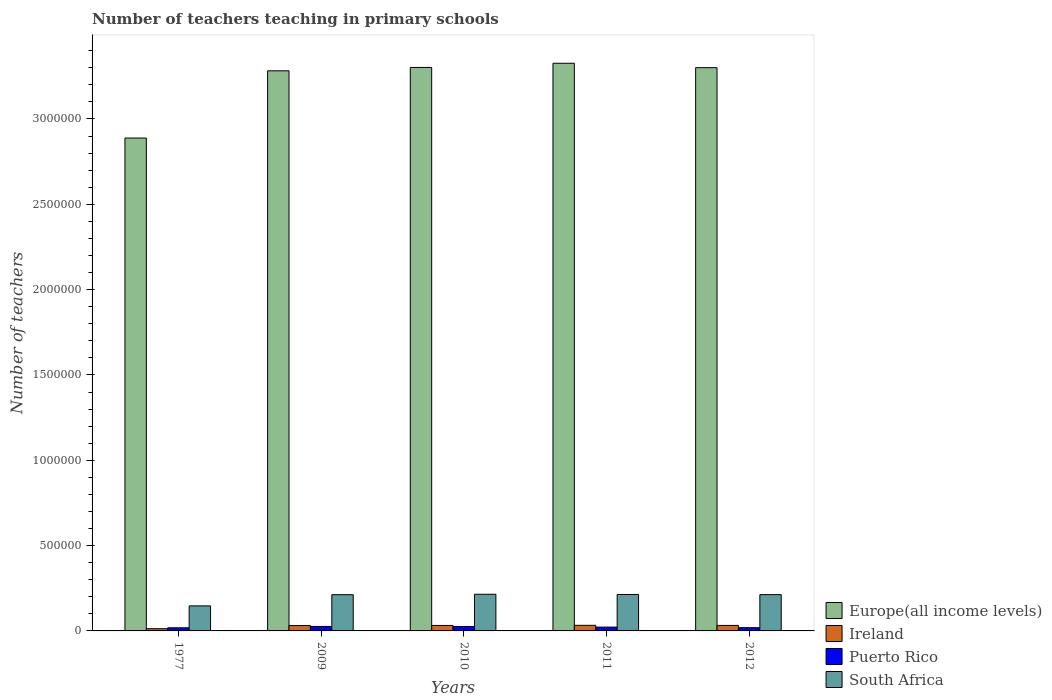How many different coloured bars are there?
Your answer should be very brief. 4. Are the number of bars on each tick of the X-axis equal?
Give a very brief answer. Yes. What is the label of the 5th group of bars from the left?
Your response must be concise. 2012. In how many cases, is the number of bars for a given year not equal to the number of legend labels?
Offer a very short reply. 0. What is the number of teachers teaching in primary schools in Puerto Rico in 1977?
Your response must be concise. 1.83e+04. Across all years, what is the maximum number of teachers teaching in primary schools in Europe(all income levels)?
Ensure brevity in your answer.  3.33e+06. Across all years, what is the minimum number of teachers teaching in primary schools in South Africa?
Keep it short and to the point. 1.47e+05. In which year was the number of teachers teaching in primary schools in Europe(all income levels) maximum?
Provide a succinct answer. 2011. What is the total number of teachers teaching in primary schools in Europe(all income levels) in the graph?
Give a very brief answer. 1.61e+07. What is the difference between the number of teachers teaching in primary schools in Europe(all income levels) in 2009 and that in 2012?
Your answer should be compact. -1.84e+04. What is the difference between the number of teachers teaching in primary schools in South Africa in 2011 and the number of teachers teaching in primary schools in Europe(all income levels) in 2010?
Ensure brevity in your answer.  -3.09e+06. What is the average number of teachers teaching in primary schools in Europe(all income levels) per year?
Ensure brevity in your answer.  3.22e+06. In the year 1977, what is the difference between the number of teachers teaching in primary schools in Puerto Rico and number of teachers teaching in primary schools in Ireland?
Your response must be concise. 5264. In how many years, is the number of teachers teaching in primary schools in Ireland greater than 3300000?
Keep it short and to the point. 0. What is the ratio of the number of teachers teaching in primary schools in South Africa in 1977 to that in 2009?
Your answer should be compact. 0.69. Is the number of teachers teaching in primary schools in Ireland in 1977 less than that in 2009?
Make the answer very short. Yes. What is the difference between the highest and the second highest number of teachers teaching in primary schools in Ireland?
Provide a short and direct response. 581. What is the difference between the highest and the lowest number of teachers teaching in primary schools in South Africa?
Give a very brief answer. 6.81e+04. What does the 4th bar from the left in 2010 represents?
Ensure brevity in your answer.  South Africa. What does the 4th bar from the right in 2011 represents?
Give a very brief answer. Europe(all income levels). How many bars are there?
Keep it short and to the point. 20. How many years are there in the graph?
Ensure brevity in your answer.  5. What is the difference between two consecutive major ticks on the Y-axis?
Keep it short and to the point. 5.00e+05. Does the graph contain any zero values?
Provide a succinct answer. No. Does the graph contain grids?
Your answer should be very brief. No. Where does the legend appear in the graph?
Give a very brief answer. Bottom right. How many legend labels are there?
Provide a short and direct response. 4. What is the title of the graph?
Your answer should be very brief. Number of teachers teaching in primary schools. Does "Benin" appear as one of the legend labels in the graph?
Offer a very short reply. No. What is the label or title of the Y-axis?
Give a very brief answer. Number of teachers. What is the Number of teachers in Europe(all income levels) in 1977?
Ensure brevity in your answer.  2.89e+06. What is the Number of teachers of Ireland in 1977?
Your response must be concise. 1.31e+04. What is the Number of teachers in Puerto Rico in 1977?
Offer a very short reply. 1.83e+04. What is the Number of teachers of South Africa in 1977?
Your answer should be compact. 1.47e+05. What is the Number of teachers of Europe(all income levels) in 2009?
Provide a short and direct response. 3.28e+06. What is the Number of teachers in Ireland in 2009?
Your answer should be very brief. 3.15e+04. What is the Number of teachers of Puerto Rico in 2009?
Your answer should be compact. 2.61e+04. What is the Number of teachers in South Africa in 2009?
Offer a terse response. 2.12e+05. What is the Number of teachers of Europe(all income levels) in 2010?
Your response must be concise. 3.30e+06. What is the Number of teachers of Ireland in 2010?
Your answer should be compact. 3.20e+04. What is the Number of teachers in Puerto Rico in 2010?
Offer a terse response. 2.57e+04. What is the Number of teachers of South Africa in 2010?
Give a very brief answer. 2.15e+05. What is the Number of teachers in Europe(all income levels) in 2011?
Your answer should be very brief. 3.33e+06. What is the Number of teachers of Ireland in 2011?
Keep it short and to the point. 3.28e+04. What is the Number of teachers of Puerto Rico in 2011?
Offer a terse response. 2.24e+04. What is the Number of teachers in South Africa in 2011?
Your answer should be very brief. 2.13e+05. What is the Number of teachers in Europe(all income levels) in 2012?
Give a very brief answer. 3.30e+06. What is the Number of teachers of Ireland in 2012?
Offer a terse response. 3.23e+04. What is the Number of teachers in Puerto Rico in 2012?
Your response must be concise. 1.91e+04. What is the Number of teachers of South Africa in 2012?
Give a very brief answer. 2.13e+05. Across all years, what is the maximum Number of teachers of Europe(all income levels)?
Give a very brief answer. 3.33e+06. Across all years, what is the maximum Number of teachers of Ireland?
Make the answer very short. 3.28e+04. Across all years, what is the maximum Number of teachers in Puerto Rico?
Provide a succinct answer. 2.61e+04. Across all years, what is the maximum Number of teachers of South Africa?
Provide a short and direct response. 2.15e+05. Across all years, what is the minimum Number of teachers in Europe(all income levels)?
Your response must be concise. 2.89e+06. Across all years, what is the minimum Number of teachers in Ireland?
Provide a succinct answer. 1.31e+04. Across all years, what is the minimum Number of teachers of Puerto Rico?
Provide a succinct answer. 1.83e+04. Across all years, what is the minimum Number of teachers in South Africa?
Your answer should be compact. 1.47e+05. What is the total Number of teachers of Europe(all income levels) in the graph?
Ensure brevity in your answer.  1.61e+07. What is the total Number of teachers of Ireland in the graph?
Your answer should be compact. 1.42e+05. What is the total Number of teachers of Puerto Rico in the graph?
Offer a very short reply. 1.12e+05. What is the total Number of teachers in South Africa in the graph?
Make the answer very short. 1.00e+06. What is the difference between the Number of teachers of Europe(all income levels) in 1977 and that in 2009?
Give a very brief answer. -3.94e+05. What is the difference between the Number of teachers of Ireland in 1977 and that in 2009?
Offer a terse response. -1.85e+04. What is the difference between the Number of teachers of Puerto Rico in 1977 and that in 2009?
Give a very brief answer. -7718. What is the difference between the Number of teachers in South Africa in 1977 and that in 2009?
Offer a terse response. -6.55e+04. What is the difference between the Number of teachers of Europe(all income levels) in 1977 and that in 2010?
Ensure brevity in your answer.  -4.14e+05. What is the difference between the Number of teachers of Ireland in 1977 and that in 2010?
Provide a succinct answer. -1.90e+04. What is the difference between the Number of teachers of Puerto Rico in 1977 and that in 2010?
Make the answer very short. -7368. What is the difference between the Number of teachers in South Africa in 1977 and that in 2010?
Make the answer very short. -6.81e+04. What is the difference between the Number of teachers of Europe(all income levels) in 1977 and that in 2011?
Provide a succinct answer. -4.38e+05. What is the difference between the Number of teachers of Ireland in 1977 and that in 2011?
Provide a short and direct response. -1.98e+04. What is the difference between the Number of teachers of Puerto Rico in 1977 and that in 2011?
Make the answer very short. -4055. What is the difference between the Number of teachers of South Africa in 1977 and that in 2011?
Offer a very short reply. -6.67e+04. What is the difference between the Number of teachers in Europe(all income levels) in 1977 and that in 2012?
Your response must be concise. -4.12e+05. What is the difference between the Number of teachers of Ireland in 1977 and that in 2012?
Your response must be concise. -1.92e+04. What is the difference between the Number of teachers of Puerto Rico in 1977 and that in 2012?
Ensure brevity in your answer.  -741. What is the difference between the Number of teachers of South Africa in 1977 and that in 2012?
Keep it short and to the point. -6.59e+04. What is the difference between the Number of teachers in Europe(all income levels) in 2009 and that in 2010?
Offer a terse response. -1.97e+04. What is the difference between the Number of teachers of Ireland in 2009 and that in 2010?
Keep it short and to the point. -494. What is the difference between the Number of teachers in Puerto Rico in 2009 and that in 2010?
Offer a very short reply. 350. What is the difference between the Number of teachers in South Africa in 2009 and that in 2010?
Provide a short and direct response. -2584. What is the difference between the Number of teachers of Europe(all income levels) in 2009 and that in 2011?
Give a very brief answer. -4.43e+04. What is the difference between the Number of teachers of Ireland in 2009 and that in 2011?
Offer a very short reply. -1299. What is the difference between the Number of teachers of Puerto Rico in 2009 and that in 2011?
Offer a very short reply. 3663. What is the difference between the Number of teachers in South Africa in 2009 and that in 2011?
Ensure brevity in your answer.  -1144. What is the difference between the Number of teachers in Europe(all income levels) in 2009 and that in 2012?
Give a very brief answer. -1.84e+04. What is the difference between the Number of teachers of Ireland in 2009 and that in 2012?
Give a very brief answer. -718. What is the difference between the Number of teachers of Puerto Rico in 2009 and that in 2012?
Make the answer very short. 6977. What is the difference between the Number of teachers of South Africa in 2009 and that in 2012?
Provide a short and direct response. -361. What is the difference between the Number of teachers of Europe(all income levels) in 2010 and that in 2011?
Offer a terse response. -2.46e+04. What is the difference between the Number of teachers of Ireland in 2010 and that in 2011?
Your answer should be compact. -805. What is the difference between the Number of teachers of Puerto Rico in 2010 and that in 2011?
Give a very brief answer. 3313. What is the difference between the Number of teachers of South Africa in 2010 and that in 2011?
Your answer should be very brief. 1440. What is the difference between the Number of teachers in Europe(all income levels) in 2010 and that in 2012?
Offer a very short reply. 1240.5. What is the difference between the Number of teachers of Ireland in 2010 and that in 2012?
Your response must be concise. -224. What is the difference between the Number of teachers of Puerto Rico in 2010 and that in 2012?
Provide a succinct answer. 6627. What is the difference between the Number of teachers in South Africa in 2010 and that in 2012?
Your answer should be compact. 2223. What is the difference between the Number of teachers of Europe(all income levels) in 2011 and that in 2012?
Your answer should be very brief. 2.58e+04. What is the difference between the Number of teachers in Ireland in 2011 and that in 2012?
Your answer should be very brief. 581. What is the difference between the Number of teachers in Puerto Rico in 2011 and that in 2012?
Ensure brevity in your answer.  3314. What is the difference between the Number of teachers in South Africa in 2011 and that in 2012?
Provide a succinct answer. 783. What is the difference between the Number of teachers in Europe(all income levels) in 1977 and the Number of teachers in Ireland in 2009?
Offer a terse response. 2.86e+06. What is the difference between the Number of teachers in Europe(all income levels) in 1977 and the Number of teachers in Puerto Rico in 2009?
Offer a terse response. 2.86e+06. What is the difference between the Number of teachers of Europe(all income levels) in 1977 and the Number of teachers of South Africa in 2009?
Your answer should be compact. 2.68e+06. What is the difference between the Number of teachers in Ireland in 1977 and the Number of teachers in Puerto Rico in 2009?
Your response must be concise. -1.30e+04. What is the difference between the Number of teachers of Ireland in 1977 and the Number of teachers of South Africa in 2009?
Ensure brevity in your answer.  -1.99e+05. What is the difference between the Number of teachers in Puerto Rico in 1977 and the Number of teachers in South Africa in 2009?
Keep it short and to the point. -1.94e+05. What is the difference between the Number of teachers in Europe(all income levels) in 1977 and the Number of teachers in Ireland in 2010?
Provide a succinct answer. 2.86e+06. What is the difference between the Number of teachers in Europe(all income levels) in 1977 and the Number of teachers in Puerto Rico in 2010?
Your answer should be very brief. 2.86e+06. What is the difference between the Number of teachers of Europe(all income levels) in 1977 and the Number of teachers of South Africa in 2010?
Provide a short and direct response. 2.67e+06. What is the difference between the Number of teachers of Ireland in 1977 and the Number of teachers of Puerto Rico in 2010?
Keep it short and to the point. -1.26e+04. What is the difference between the Number of teachers of Ireland in 1977 and the Number of teachers of South Africa in 2010?
Provide a succinct answer. -2.02e+05. What is the difference between the Number of teachers of Puerto Rico in 1977 and the Number of teachers of South Africa in 2010?
Ensure brevity in your answer.  -1.97e+05. What is the difference between the Number of teachers in Europe(all income levels) in 1977 and the Number of teachers in Ireland in 2011?
Ensure brevity in your answer.  2.86e+06. What is the difference between the Number of teachers in Europe(all income levels) in 1977 and the Number of teachers in Puerto Rico in 2011?
Provide a short and direct response. 2.87e+06. What is the difference between the Number of teachers in Europe(all income levels) in 1977 and the Number of teachers in South Africa in 2011?
Give a very brief answer. 2.67e+06. What is the difference between the Number of teachers of Ireland in 1977 and the Number of teachers of Puerto Rico in 2011?
Ensure brevity in your answer.  -9319. What is the difference between the Number of teachers in Ireland in 1977 and the Number of teachers in South Africa in 2011?
Keep it short and to the point. -2.00e+05. What is the difference between the Number of teachers in Puerto Rico in 1977 and the Number of teachers in South Africa in 2011?
Make the answer very short. -1.95e+05. What is the difference between the Number of teachers in Europe(all income levels) in 1977 and the Number of teachers in Ireland in 2012?
Your answer should be very brief. 2.86e+06. What is the difference between the Number of teachers of Europe(all income levels) in 1977 and the Number of teachers of Puerto Rico in 2012?
Give a very brief answer. 2.87e+06. What is the difference between the Number of teachers of Europe(all income levels) in 1977 and the Number of teachers of South Africa in 2012?
Your answer should be very brief. 2.68e+06. What is the difference between the Number of teachers of Ireland in 1977 and the Number of teachers of Puerto Rico in 2012?
Keep it short and to the point. -6005. What is the difference between the Number of teachers in Ireland in 1977 and the Number of teachers in South Africa in 2012?
Make the answer very short. -2.00e+05. What is the difference between the Number of teachers in Puerto Rico in 1977 and the Number of teachers in South Africa in 2012?
Offer a terse response. -1.94e+05. What is the difference between the Number of teachers of Europe(all income levels) in 2009 and the Number of teachers of Ireland in 2010?
Your answer should be compact. 3.25e+06. What is the difference between the Number of teachers of Europe(all income levels) in 2009 and the Number of teachers of Puerto Rico in 2010?
Offer a very short reply. 3.26e+06. What is the difference between the Number of teachers in Europe(all income levels) in 2009 and the Number of teachers in South Africa in 2010?
Your answer should be very brief. 3.07e+06. What is the difference between the Number of teachers of Ireland in 2009 and the Number of teachers of Puerto Rico in 2010?
Ensure brevity in your answer.  5841. What is the difference between the Number of teachers of Ireland in 2009 and the Number of teachers of South Africa in 2010?
Offer a terse response. -1.83e+05. What is the difference between the Number of teachers of Puerto Rico in 2009 and the Number of teachers of South Africa in 2010?
Ensure brevity in your answer.  -1.89e+05. What is the difference between the Number of teachers in Europe(all income levels) in 2009 and the Number of teachers in Ireland in 2011?
Your answer should be very brief. 3.25e+06. What is the difference between the Number of teachers in Europe(all income levels) in 2009 and the Number of teachers in Puerto Rico in 2011?
Offer a terse response. 3.26e+06. What is the difference between the Number of teachers in Europe(all income levels) in 2009 and the Number of teachers in South Africa in 2011?
Make the answer very short. 3.07e+06. What is the difference between the Number of teachers of Ireland in 2009 and the Number of teachers of Puerto Rico in 2011?
Provide a short and direct response. 9154. What is the difference between the Number of teachers of Ireland in 2009 and the Number of teachers of South Africa in 2011?
Your answer should be compact. -1.82e+05. What is the difference between the Number of teachers in Puerto Rico in 2009 and the Number of teachers in South Africa in 2011?
Your answer should be very brief. -1.87e+05. What is the difference between the Number of teachers in Europe(all income levels) in 2009 and the Number of teachers in Ireland in 2012?
Your answer should be compact. 3.25e+06. What is the difference between the Number of teachers in Europe(all income levels) in 2009 and the Number of teachers in Puerto Rico in 2012?
Provide a succinct answer. 3.26e+06. What is the difference between the Number of teachers in Europe(all income levels) in 2009 and the Number of teachers in South Africa in 2012?
Your answer should be very brief. 3.07e+06. What is the difference between the Number of teachers of Ireland in 2009 and the Number of teachers of Puerto Rico in 2012?
Your response must be concise. 1.25e+04. What is the difference between the Number of teachers of Ireland in 2009 and the Number of teachers of South Africa in 2012?
Give a very brief answer. -1.81e+05. What is the difference between the Number of teachers of Puerto Rico in 2009 and the Number of teachers of South Africa in 2012?
Your answer should be very brief. -1.87e+05. What is the difference between the Number of teachers of Europe(all income levels) in 2010 and the Number of teachers of Ireland in 2011?
Provide a short and direct response. 3.27e+06. What is the difference between the Number of teachers of Europe(all income levels) in 2010 and the Number of teachers of Puerto Rico in 2011?
Your answer should be very brief. 3.28e+06. What is the difference between the Number of teachers in Europe(all income levels) in 2010 and the Number of teachers in South Africa in 2011?
Ensure brevity in your answer.  3.09e+06. What is the difference between the Number of teachers in Ireland in 2010 and the Number of teachers in Puerto Rico in 2011?
Your answer should be compact. 9648. What is the difference between the Number of teachers in Ireland in 2010 and the Number of teachers in South Africa in 2011?
Ensure brevity in your answer.  -1.81e+05. What is the difference between the Number of teachers of Puerto Rico in 2010 and the Number of teachers of South Africa in 2011?
Make the answer very short. -1.88e+05. What is the difference between the Number of teachers in Europe(all income levels) in 2010 and the Number of teachers in Ireland in 2012?
Make the answer very short. 3.27e+06. What is the difference between the Number of teachers in Europe(all income levels) in 2010 and the Number of teachers in Puerto Rico in 2012?
Your answer should be compact. 3.28e+06. What is the difference between the Number of teachers in Europe(all income levels) in 2010 and the Number of teachers in South Africa in 2012?
Your response must be concise. 3.09e+06. What is the difference between the Number of teachers in Ireland in 2010 and the Number of teachers in Puerto Rico in 2012?
Keep it short and to the point. 1.30e+04. What is the difference between the Number of teachers of Ireland in 2010 and the Number of teachers of South Africa in 2012?
Provide a succinct answer. -1.81e+05. What is the difference between the Number of teachers in Puerto Rico in 2010 and the Number of teachers in South Africa in 2012?
Provide a succinct answer. -1.87e+05. What is the difference between the Number of teachers of Europe(all income levels) in 2011 and the Number of teachers of Ireland in 2012?
Give a very brief answer. 3.29e+06. What is the difference between the Number of teachers in Europe(all income levels) in 2011 and the Number of teachers in Puerto Rico in 2012?
Offer a very short reply. 3.31e+06. What is the difference between the Number of teachers in Europe(all income levels) in 2011 and the Number of teachers in South Africa in 2012?
Your response must be concise. 3.11e+06. What is the difference between the Number of teachers of Ireland in 2011 and the Number of teachers of Puerto Rico in 2012?
Keep it short and to the point. 1.38e+04. What is the difference between the Number of teachers in Ireland in 2011 and the Number of teachers in South Africa in 2012?
Offer a very short reply. -1.80e+05. What is the difference between the Number of teachers in Puerto Rico in 2011 and the Number of teachers in South Africa in 2012?
Offer a terse response. -1.90e+05. What is the average Number of teachers in Europe(all income levels) per year?
Ensure brevity in your answer.  3.22e+06. What is the average Number of teachers of Ireland per year?
Provide a short and direct response. 2.84e+04. What is the average Number of teachers of Puerto Rico per year?
Ensure brevity in your answer.  2.23e+04. What is the average Number of teachers in South Africa per year?
Make the answer very short. 2.00e+05. In the year 1977, what is the difference between the Number of teachers of Europe(all income levels) and Number of teachers of Ireland?
Your answer should be compact. 2.88e+06. In the year 1977, what is the difference between the Number of teachers in Europe(all income levels) and Number of teachers in Puerto Rico?
Keep it short and to the point. 2.87e+06. In the year 1977, what is the difference between the Number of teachers in Europe(all income levels) and Number of teachers in South Africa?
Offer a very short reply. 2.74e+06. In the year 1977, what is the difference between the Number of teachers in Ireland and Number of teachers in Puerto Rico?
Give a very brief answer. -5264. In the year 1977, what is the difference between the Number of teachers in Ireland and Number of teachers in South Africa?
Offer a terse response. -1.34e+05. In the year 1977, what is the difference between the Number of teachers of Puerto Rico and Number of teachers of South Africa?
Ensure brevity in your answer.  -1.28e+05. In the year 2009, what is the difference between the Number of teachers in Europe(all income levels) and Number of teachers in Ireland?
Provide a short and direct response. 3.25e+06. In the year 2009, what is the difference between the Number of teachers in Europe(all income levels) and Number of teachers in Puerto Rico?
Give a very brief answer. 3.26e+06. In the year 2009, what is the difference between the Number of teachers of Europe(all income levels) and Number of teachers of South Africa?
Your answer should be compact. 3.07e+06. In the year 2009, what is the difference between the Number of teachers of Ireland and Number of teachers of Puerto Rico?
Offer a very short reply. 5491. In the year 2009, what is the difference between the Number of teachers of Ireland and Number of teachers of South Africa?
Keep it short and to the point. -1.81e+05. In the year 2009, what is the difference between the Number of teachers of Puerto Rico and Number of teachers of South Africa?
Your answer should be very brief. -1.86e+05. In the year 2010, what is the difference between the Number of teachers of Europe(all income levels) and Number of teachers of Ireland?
Ensure brevity in your answer.  3.27e+06. In the year 2010, what is the difference between the Number of teachers of Europe(all income levels) and Number of teachers of Puerto Rico?
Your answer should be compact. 3.28e+06. In the year 2010, what is the difference between the Number of teachers of Europe(all income levels) and Number of teachers of South Africa?
Provide a succinct answer. 3.09e+06. In the year 2010, what is the difference between the Number of teachers of Ireland and Number of teachers of Puerto Rico?
Give a very brief answer. 6335. In the year 2010, what is the difference between the Number of teachers in Ireland and Number of teachers in South Africa?
Your answer should be compact. -1.83e+05. In the year 2010, what is the difference between the Number of teachers of Puerto Rico and Number of teachers of South Africa?
Keep it short and to the point. -1.89e+05. In the year 2011, what is the difference between the Number of teachers in Europe(all income levels) and Number of teachers in Ireland?
Your answer should be very brief. 3.29e+06. In the year 2011, what is the difference between the Number of teachers in Europe(all income levels) and Number of teachers in Puerto Rico?
Offer a terse response. 3.30e+06. In the year 2011, what is the difference between the Number of teachers of Europe(all income levels) and Number of teachers of South Africa?
Your response must be concise. 3.11e+06. In the year 2011, what is the difference between the Number of teachers in Ireland and Number of teachers in Puerto Rico?
Your response must be concise. 1.05e+04. In the year 2011, what is the difference between the Number of teachers of Ireland and Number of teachers of South Africa?
Offer a terse response. -1.81e+05. In the year 2011, what is the difference between the Number of teachers in Puerto Rico and Number of teachers in South Africa?
Your answer should be compact. -1.91e+05. In the year 2012, what is the difference between the Number of teachers in Europe(all income levels) and Number of teachers in Ireland?
Offer a terse response. 3.27e+06. In the year 2012, what is the difference between the Number of teachers in Europe(all income levels) and Number of teachers in Puerto Rico?
Make the answer very short. 3.28e+06. In the year 2012, what is the difference between the Number of teachers of Europe(all income levels) and Number of teachers of South Africa?
Ensure brevity in your answer.  3.09e+06. In the year 2012, what is the difference between the Number of teachers of Ireland and Number of teachers of Puerto Rico?
Ensure brevity in your answer.  1.32e+04. In the year 2012, what is the difference between the Number of teachers of Ireland and Number of teachers of South Africa?
Make the answer very short. -1.80e+05. In the year 2012, what is the difference between the Number of teachers of Puerto Rico and Number of teachers of South Africa?
Provide a succinct answer. -1.94e+05. What is the ratio of the Number of teachers of Europe(all income levels) in 1977 to that in 2009?
Offer a very short reply. 0.88. What is the ratio of the Number of teachers in Ireland in 1977 to that in 2009?
Offer a terse response. 0.41. What is the ratio of the Number of teachers in Puerto Rico in 1977 to that in 2009?
Your answer should be compact. 0.7. What is the ratio of the Number of teachers of South Africa in 1977 to that in 2009?
Provide a short and direct response. 0.69. What is the ratio of the Number of teachers of Europe(all income levels) in 1977 to that in 2010?
Make the answer very short. 0.87. What is the ratio of the Number of teachers of Ireland in 1977 to that in 2010?
Keep it short and to the point. 0.41. What is the ratio of the Number of teachers of Puerto Rico in 1977 to that in 2010?
Provide a succinct answer. 0.71. What is the ratio of the Number of teachers of South Africa in 1977 to that in 2010?
Your response must be concise. 0.68. What is the ratio of the Number of teachers of Europe(all income levels) in 1977 to that in 2011?
Offer a terse response. 0.87. What is the ratio of the Number of teachers of Ireland in 1977 to that in 2011?
Provide a short and direct response. 0.4. What is the ratio of the Number of teachers of Puerto Rico in 1977 to that in 2011?
Give a very brief answer. 0.82. What is the ratio of the Number of teachers in South Africa in 1977 to that in 2011?
Provide a short and direct response. 0.69. What is the ratio of the Number of teachers in Europe(all income levels) in 1977 to that in 2012?
Your response must be concise. 0.88. What is the ratio of the Number of teachers in Ireland in 1977 to that in 2012?
Provide a succinct answer. 0.41. What is the ratio of the Number of teachers of Puerto Rico in 1977 to that in 2012?
Offer a terse response. 0.96. What is the ratio of the Number of teachers in South Africa in 1977 to that in 2012?
Your answer should be very brief. 0.69. What is the ratio of the Number of teachers in Europe(all income levels) in 2009 to that in 2010?
Give a very brief answer. 0.99. What is the ratio of the Number of teachers of Ireland in 2009 to that in 2010?
Your answer should be very brief. 0.98. What is the ratio of the Number of teachers of Puerto Rico in 2009 to that in 2010?
Offer a very short reply. 1.01. What is the ratio of the Number of teachers of Europe(all income levels) in 2009 to that in 2011?
Keep it short and to the point. 0.99. What is the ratio of the Number of teachers in Ireland in 2009 to that in 2011?
Give a very brief answer. 0.96. What is the ratio of the Number of teachers in Puerto Rico in 2009 to that in 2011?
Make the answer very short. 1.16. What is the ratio of the Number of teachers of Ireland in 2009 to that in 2012?
Ensure brevity in your answer.  0.98. What is the ratio of the Number of teachers in Puerto Rico in 2009 to that in 2012?
Provide a succinct answer. 1.37. What is the ratio of the Number of teachers of South Africa in 2009 to that in 2012?
Ensure brevity in your answer.  1. What is the ratio of the Number of teachers of Europe(all income levels) in 2010 to that in 2011?
Provide a succinct answer. 0.99. What is the ratio of the Number of teachers of Ireland in 2010 to that in 2011?
Provide a short and direct response. 0.98. What is the ratio of the Number of teachers in Puerto Rico in 2010 to that in 2011?
Offer a terse response. 1.15. What is the ratio of the Number of teachers of South Africa in 2010 to that in 2011?
Give a very brief answer. 1.01. What is the ratio of the Number of teachers of Europe(all income levels) in 2010 to that in 2012?
Keep it short and to the point. 1. What is the ratio of the Number of teachers of Ireland in 2010 to that in 2012?
Provide a succinct answer. 0.99. What is the ratio of the Number of teachers in Puerto Rico in 2010 to that in 2012?
Ensure brevity in your answer.  1.35. What is the ratio of the Number of teachers in South Africa in 2010 to that in 2012?
Give a very brief answer. 1.01. What is the ratio of the Number of teachers in Europe(all income levels) in 2011 to that in 2012?
Provide a short and direct response. 1.01. What is the ratio of the Number of teachers of Puerto Rico in 2011 to that in 2012?
Your answer should be very brief. 1.17. What is the ratio of the Number of teachers of South Africa in 2011 to that in 2012?
Provide a succinct answer. 1. What is the difference between the highest and the second highest Number of teachers of Europe(all income levels)?
Offer a terse response. 2.46e+04. What is the difference between the highest and the second highest Number of teachers of Ireland?
Your answer should be compact. 581. What is the difference between the highest and the second highest Number of teachers of Puerto Rico?
Provide a succinct answer. 350. What is the difference between the highest and the second highest Number of teachers of South Africa?
Provide a short and direct response. 1440. What is the difference between the highest and the lowest Number of teachers in Europe(all income levels)?
Make the answer very short. 4.38e+05. What is the difference between the highest and the lowest Number of teachers of Ireland?
Keep it short and to the point. 1.98e+04. What is the difference between the highest and the lowest Number of teachers in Puerto Rico?
Offer a very short reply. 7718. What is the difference between the highest and the lowest Number of teachers of South Africa?
Make the answer very short. 6.81e+04. 